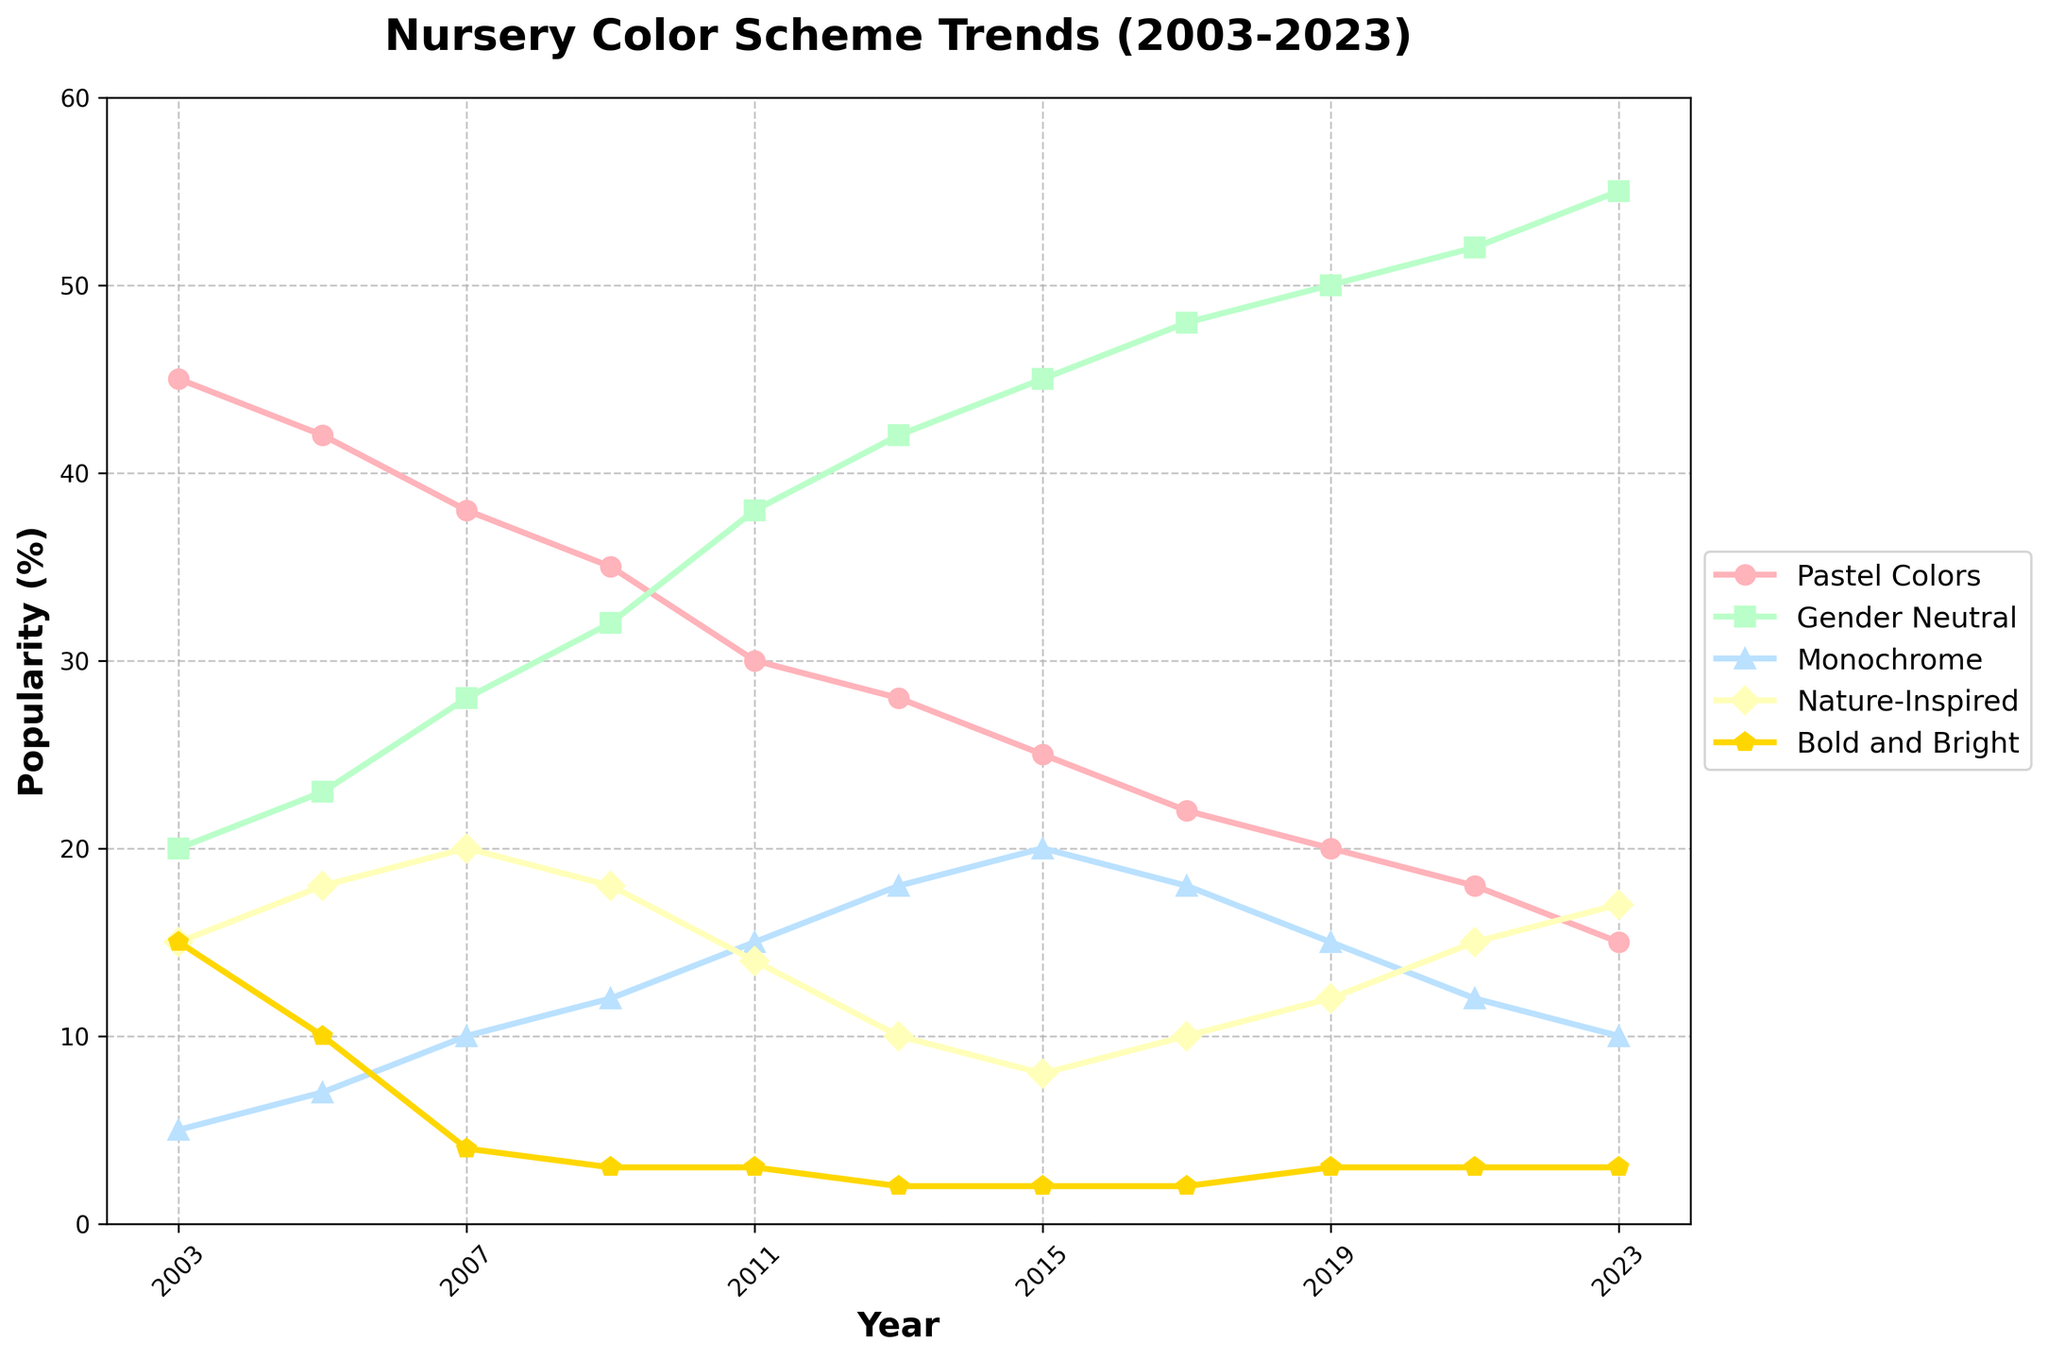What's the general trend of pastel colors' popularity from 2003 to 2023? Pastel colors showed a consistent decline in popularity over the 20-year period. Starting at 45% in 2003 and decreasing to 15% in 2023.
Answer: Declining Which color scheme became the most popular over the 20 years? Gender Neutral colors showed a steady increase becoming the most popular by 2023 with 55% popularity.
Answer: Gender Neutral In what year did monochrome colors first achieve double-digit popularity? Monochrome colors first achieved double-digit popularity in the year 2007.
Answer: 2007 By how much did the popularity of nature-inspired colors decrease from its peak in 2011 to its lowest point? Nature-Inspired peaked in 2011 at 18% and dropped to 10% in 2013, so the decrease is 18% - 10% = 8%.
Answer: 8% What is the difference in popularity percentages between Gender Neutral and Bold and Bright colors in 2023? In 2023, Gender Neutral was at 55% and Bold and Bright at 3%, so the difference is 55% - 3% = 52%.
Answer: 52% Which color scheme showed the most stability in its popularity over the years? The Bold and Bright color scheme remained fairly stable, maintaining a low but consistent popularity ranging around 2-15%.
Answer: Bold and Bright Which two color schemes had the closest popularity percentages in 2015? In 2015, Monochrome had 20% and Nature-Inspired had 8%, so the two closest color schemes are Nature-Inspired and Bold and Bright.
Answer: Nature-Inspired and Bold and Bright How much did the popularity of gender-neutral colors increase from 2003 to 2023? The popularity of Gender Neutral colors increased from 20% in 2003 to 55% in 2023, an increase of 55% - 20% = 35%.
Answer: 35% During which years did the popularity of pastels decline the most sharply? The sharpest decline in pastels happened between 2017 (22%) and 2019 (20%), a decrease of only 2%, indicating a very consistent decline over the years.
Answer: 2017-2019 What was the average popularity of monochrome colors over the 20 years? Sum the popularity percentages from 2003 to 2023 and divide by 11: (5 + 7 + 10 + 12 + 15 + 18 + 20 + 18 + 15 + 12 + 10)/11 = 142/11 ≈ 12.91.
Answer: 12.91% 